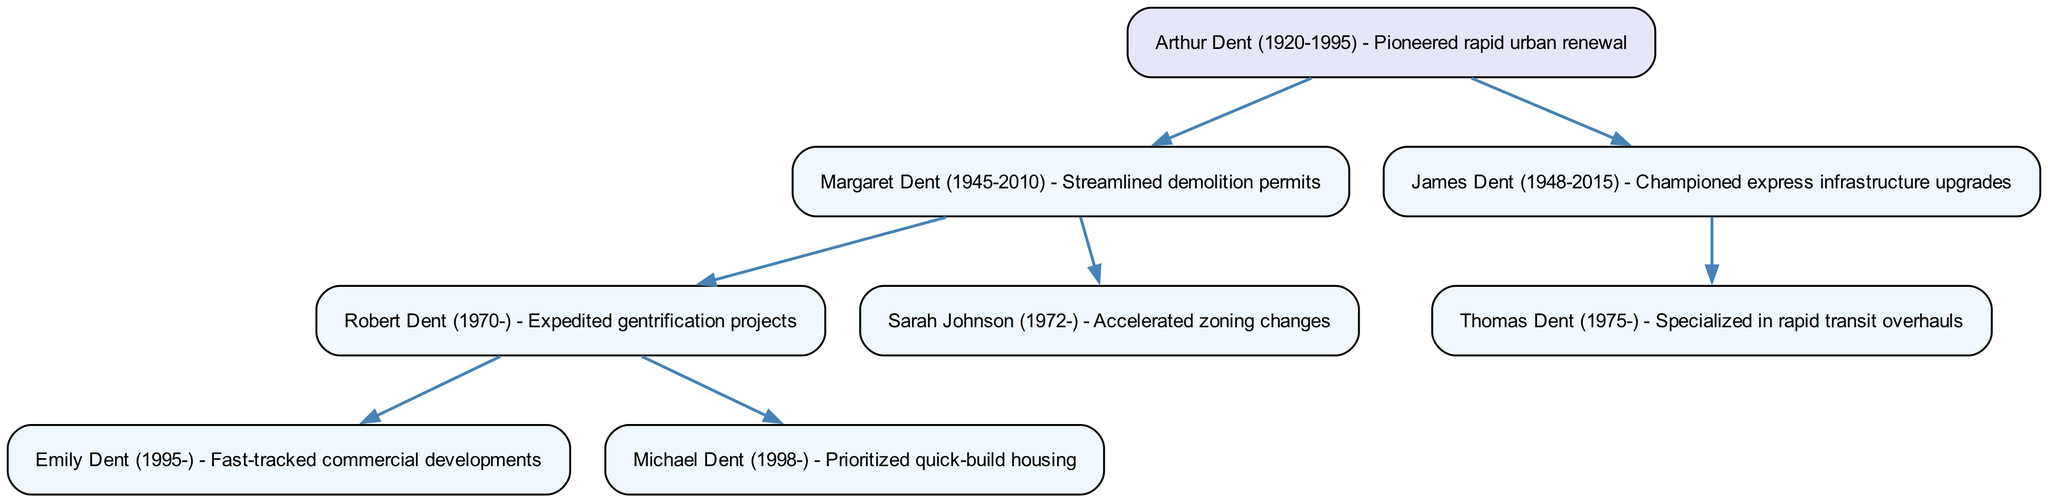What is the name of the root bureaucrat? The root of the family tree is Arthur Dent, who is described as having pioneered rapid urban renewal initiatives. Therefore, his name is associated with the foundation of this lineage.
Answer: Arthur Dent How many children does Margaret Dent have? When inspecting the children of Margaret Dent in the diagram, we see that she has two direct descendants: Robert Dent and Sarah Johnson. This can be counted directly from the visual representation.
Answer: 2 Who is known for expedited gentrification projects? In the diagram, Robert Dent is linked as the bureaucrat known for expediting gentrification projects. This is explicitly stated next to his name in the structure.
Answer: Robert Dent Which bureaucrat specialized in rapid transit overhauls? Looking at the diagram, the individual identified as specializing in rapid transit overhauls is Thomas Dent, who is the child of James Dent. This information can be derived from the hierarchical structure of the tree.
Answer: Thomas Dent What is the total number of nodes in the diagram? By counting each individual listed in the family tree, including the root, all children, and their descendants, we find there are seven nodes in total: Arthur, Margaret, James, Robert, Sarah, Emily, and Michael. This sum encompasses all positions in the family tree.
Answer: 7 Who are the children of Margaret Dent? The diagram indicates that Margaret Dent has two children: Robert Dent and Sarah Johnson. This is directly visible as they are branched out from her node.
Answer: Robert Dent, Sarah Johnson Which child of Arthur Dent has the earliest birth year? Upon reviewing the birth years listed for the children of Arthur Dent, we find that Margaret Dent was born in 1945, and James Dent was born in 1948. Since Margaret has the earlier year, she is the answer.
Answer: Margaret Dent Which bureaucrat fast-tracked commercial developments? The diagram explicitly attributes the action of fast-tracking commercial developments to Emily Dent, who is a descendant of Robert Dent. This can be verified by checking the details next to her name in the tree.
Answer: Emily Dent How many generations are represented in the diagram? The family tree can be analyzed to reveal that it spans three generations: Arthur Dent as the first generation, his children Margaret and James as the second, and the grandchildren Robert, Sarah, Emily, Michael, and Thomas as the third generation. This layer count leads to the conclusion.
Answer: 3 